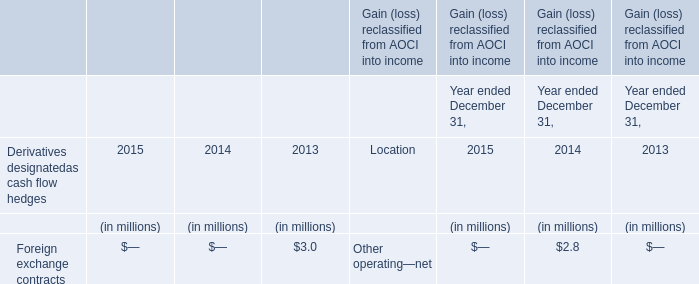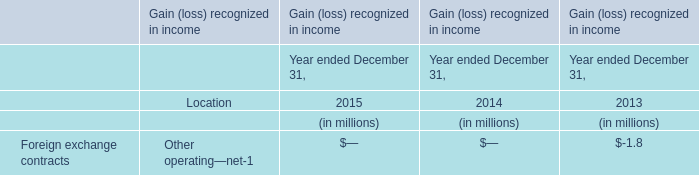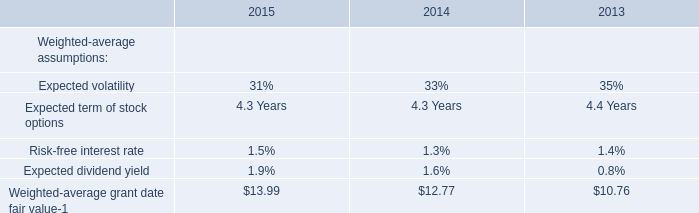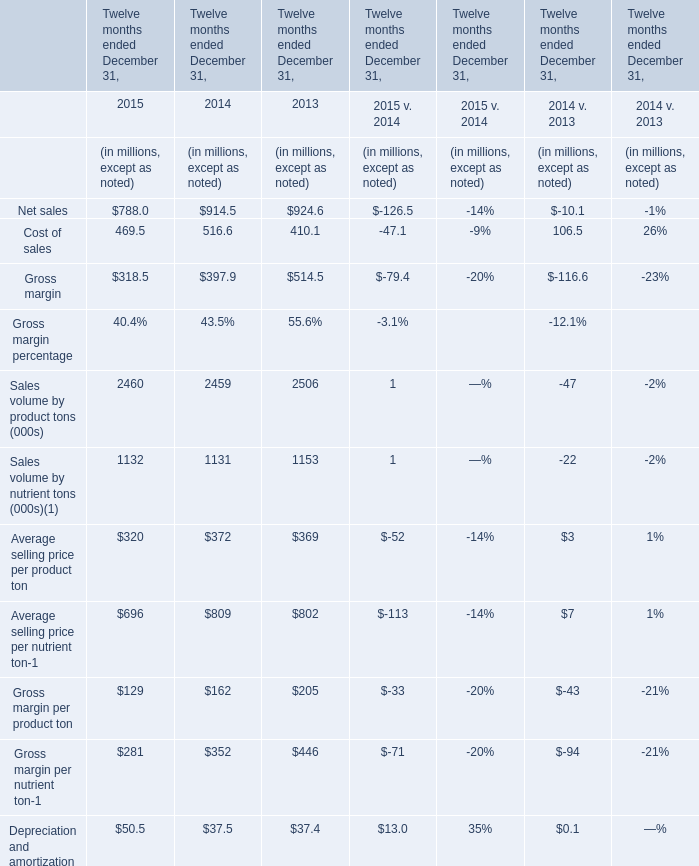What's the sum of the Net sales in the years where Foreign exchange contracts for Year ended December 31, is greater than 0? (in million) 
Computations: (516.6 + 397.9)
Answer: 914.5. 